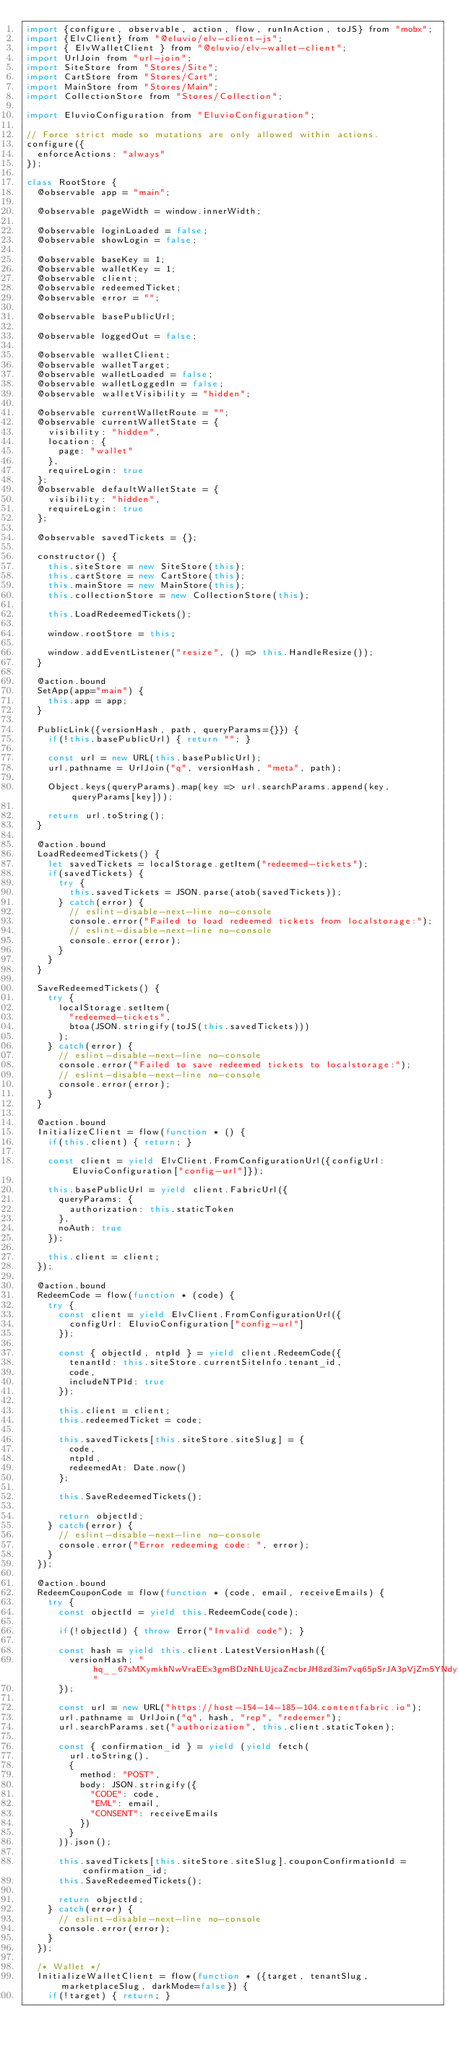Convert code to text. <code><loc_0><loc_0><loc_500><loc_500><_JavaScript_>import {configure, observable, action, flow, runInAction, toJS} from "mobx";
import {ElvClient} from "@eluvio/elv-client-js";
import { ElvWalletClient } from "@eluvio/elv-wallet-client";
import UrlJoin from "url-join";
import SiteStore from "Stores/Site";
import CartStore from "Stores/Cart";
import MainStore from "Stores/Main";
import CollectionStore from "Stores/Collection";

import EluvioConfiguration from "EluvioConfiguration";

// Force strict mode so mutations are only allowed within actions.
configure({
  enforceActions: "always"
});

class RootStore {
  @observable app = "main";

  @observable pageWidth = window.innerWidth;

  @observable loginLoaded = false;
  @observable showLogin = false;

  @observable baseKey = 1;
  @observable walletKey = 1;
  @observable client;
  @observable redeemedTicket;
  @observable error = "";

  @observable basePublicUrl;

  @observable loggedOut = false;

  @observable walletClient;
  @observable walletTarget;
  @observable walletLoaded = false;
  @observable walletLoggedIn = false;
  @observable walletVisibility = "hidden";

  @observable currentWalletRoute = "";
  @observable currentWalletState = {
    visibility: "hidden",
    location: {
      page: "wallet"
    },
    requireLogin: true
  };
  @observable defaultWalletState = {
    visibility: "hidden",
    requireLogin: true
  };

  @observable savedTickets = {};

  constructor() {
    this.siteStore = new SiteStore(this);
    this.cartStore = new CartStore(this);
    this.mainStore = new MainStore(this);
    this.collectionStore = new CollectionStore(this);

    this.LoadRedeemedTickets();

    window.rootStore = this;

    window.addEventListener("resize", () => this.HandleResize());
  }

  @action.bound
  SetApp(app="main") {
    this.app = app;
  }

  PublicLink({versionHash, path, queryParams={}}) {
    if(!this.basePublicUrl) { return ""; }

    const url = new URL(this.basePublicUrl);
    url.pathname = UrlJoin("q", versionHash, "meta", path);

    Object.keys(queryParams).map(key => url.searchParams.append(key, queryParams[key]));

    return url.toString();
  }

  @action.bound
  LoadRedeemedTickets() {
    let savedTickets = localStorage.getItem("redeemed-tickets");
    if(savedTickets) {
      try {
        this.savedTickets = JSON.parse(atob(savedTickets));
      } catch(error) {
        // eslint-disable-next-line no-console
        console.error("Failed to load redeemed tickets from localstorage:");
        // eslint-disable-next-line no-console
        console.error(error);
      }
    }
  }

  SaveRedeemedTickets() {
    try {
      localStorage.setItem(
        "redeemed-tickets",
        btoa(JSON.stringify(toJS(this.savedTickets)))
      );
    } catch(error) {
      // eslint-disable-next-line no-console
      console.error("Failed to save redeemed tickets to localstorage:");
      // eslint-disable-next-line no-console
      console.error(error);
    }
  }

  @action.bound
  InitializeClient = flow(function * () {
    if(this.client) { return; }

    const client = yield ElvClient.FromConfigurationUrl({configUrl: EluvioConfiguration["config-url"]});

    this.basePublicUrl = yield client.FabricUrl({
      queryParams: {
        authorization: this.staticToken
      },
      noAuth: true
    });

    this.client = client;
  });

  @action.bound
  RedeemCode = flow(function * (code) {
    try {
      const client = yield ElvClient.FromConfigurationUrl({
        configUrl: EluvioConfiguration["config-url"]
      });

      const { objectId, ntpId } = yield client.RedeemCode({
        tenantId: this.siteStore.currentSiteInfo.tenant_id,
        code,
        includeNTPId: true
      });

      this.client = client;
      this.redeemedTicket = code;

      this.savedTickets[this.siteStore.siteSlug] = {
        code,
        ntpId,
        redeemedAt: Date.now()
      };

      this.SaveRedeemedTickets();

      return objectId;
    } catch(error) {
      // eslint-disable-next-line no-console
      console.error("Error redeeming code: ", error);
    }
  });

  @action.bound
  RedeemCouponCode = flow(function * (code, email, receiveEmails) {
    try {
      const objectId = yield this.RedeemCode(code);

      if(!objectId) { throw Error("Invalid code"); }

      const hash = yield this.client.LatestVersionHash({
        versionHash: "hq__67sMXymkhNwVraEEx3gmBDzNhLUjcaZncbrJH8zd3im7vq65pSrJA3pVjZm5YNdy2MrtP9Qnbc"
      });

      const url = new URL("https://host-154-14-185-104.contentfabric.io");
      url.pathname = UrlJoin("q", hash, "rep", "redeemer");
      url.searchParams.set("authorization", this.client.staticToken);

      const { confirmation_id } = yield (yield fetch(
        url.toString(),
        {
          method: "POST",
          body: JSON.stringify({
            "CODE": code,
            "EML": email,
            "CONSENT": receiveEmails
          })
        }
      )).json();

      this.savedTickets[this.siteStore.siteSlug].couponConfirmationId = confirmation_id;
      this.SaveRedeemedTickets();

      return objectId;
    } catch(error) {
      // eslint-disable-next-line no-console
      console.error(error);
    }
  });

  /* Wallet */
  InitializeWalletClient = flow(function * ({target, tenantSlug, marketplaceSlug, darkMode=false}) {
    if(!target) { return; }
</code> 